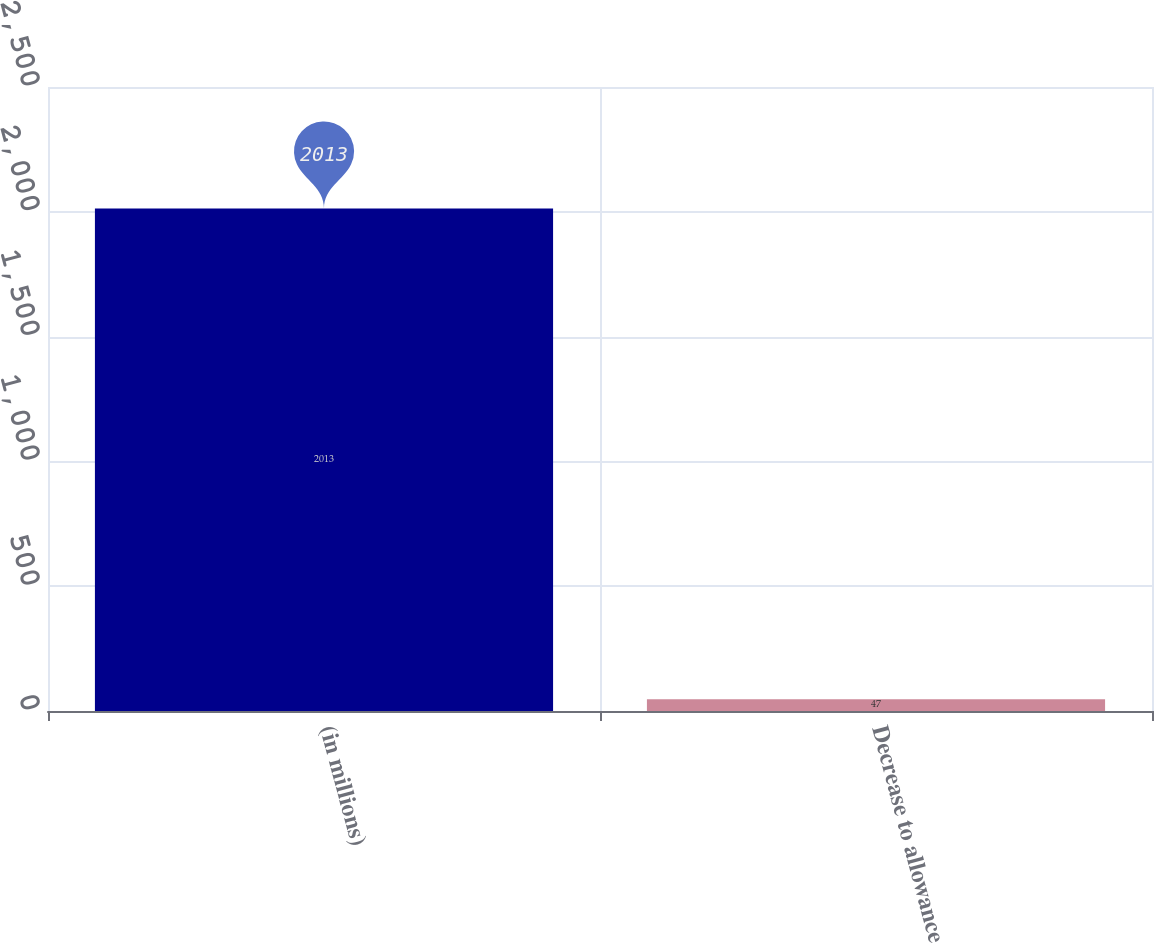Convert chart to OTSL. <chart><loc_0><loc_0><loc_500><loc_500><bar_chart><fcel>(in millions)<fcel>Decrease to allowance<nl><fcel>2013<fcel>47<nl></chart> 